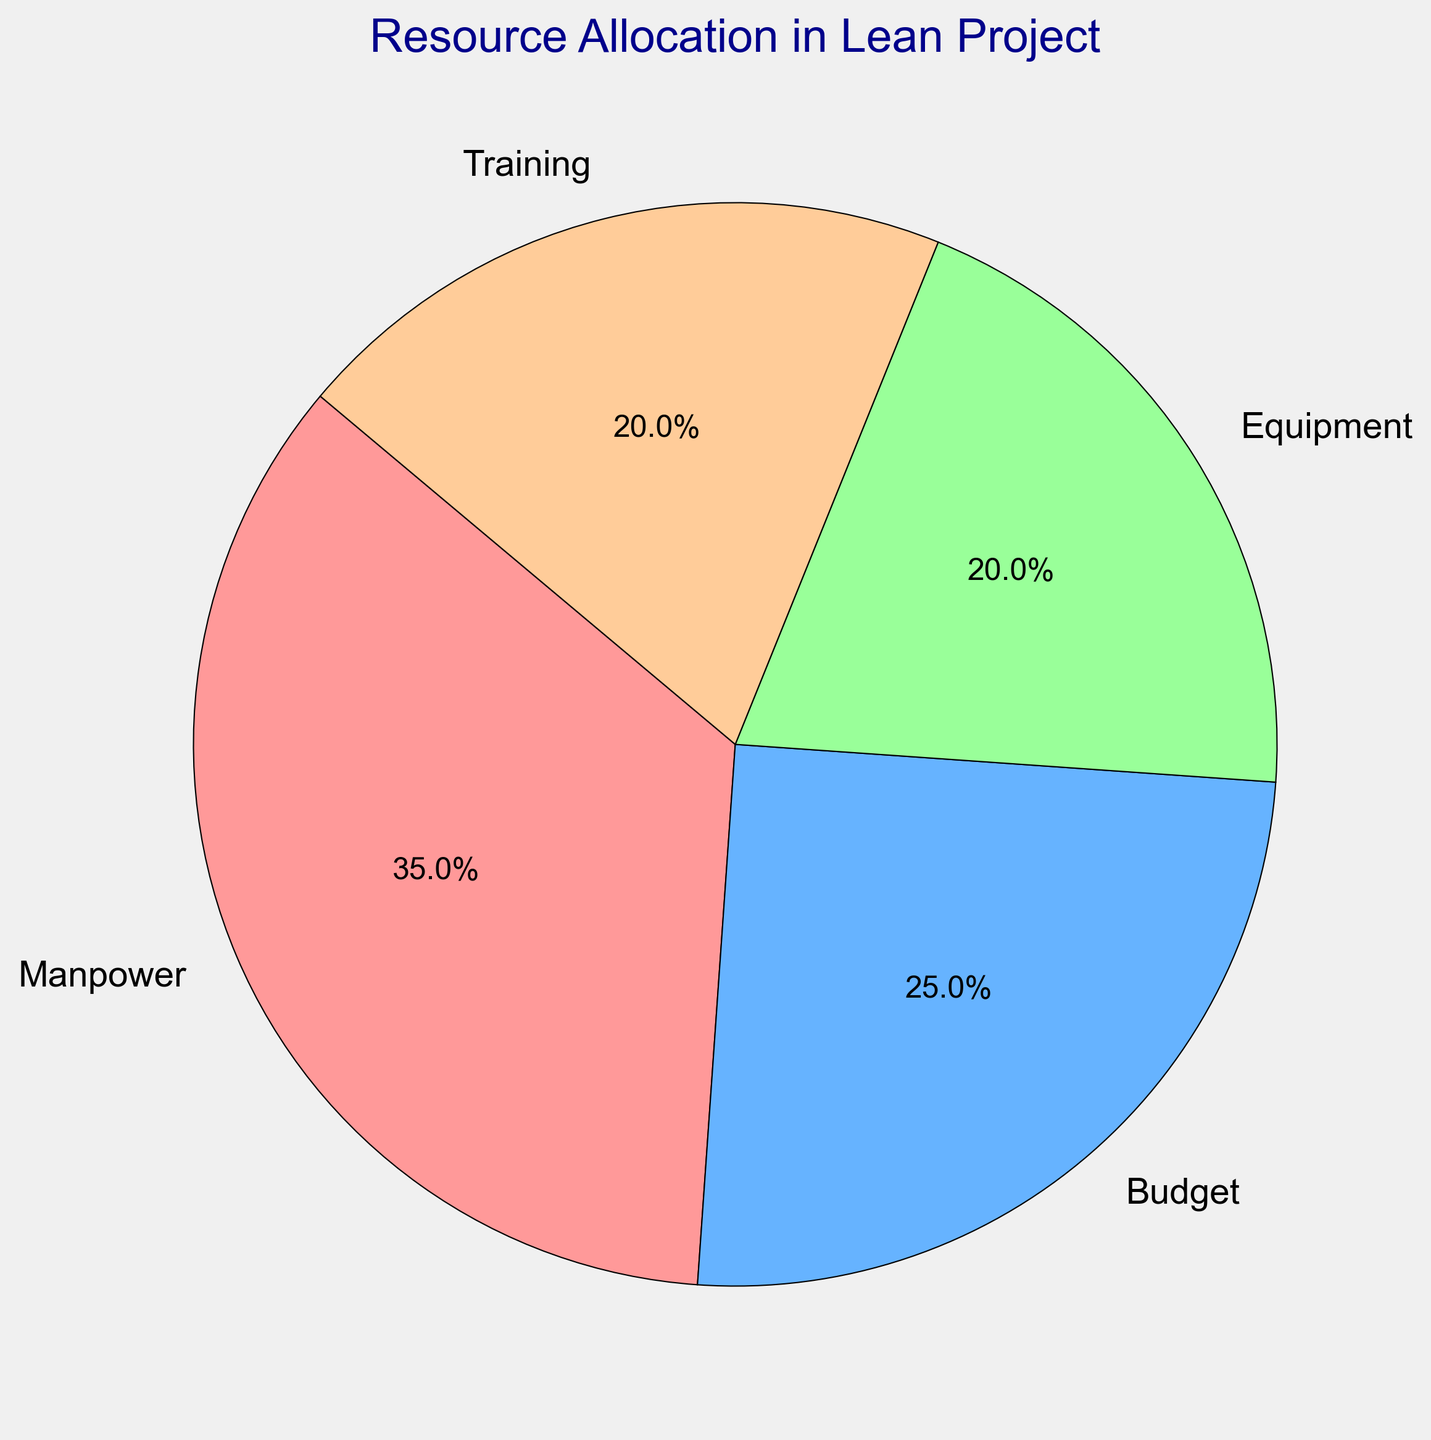What is the percentage allocated to Training? Look at the slice of the pie chart labeled "Training" and refer to the percentage written inside or next to it.
Answer: 20% Which category uses the most resources? Identify the slice of the pie chart that has the largest area and the highest percentage number. This is the category with the most resources allocated.
Answer: Manpower What's the combined percentage allocated to Equipment and Training? Add the percentage from the slices labeled "Equipment" and "Training". The Equipment slice is 20% and the Training slice is also 20%. So, 20% + 20% = 40%.
Answer: 40% How much more resource percentage is allocated to Manpower than Budget? Find the percentage for Manpower (35%) and Budget (25%) and subtract the smaller percentage from the larger one: 35% - 25% = 10%.
Answer: 10% Is the percentage allocation to Budget greater or less than that to Equipment? Compare the percentages directly from the chart: Budget is 25% and Equipment is 20%. 25% is greater than 20%, so Budget is greater.
Answer: Budget is greater What is the average percentage allocation for Equipment and Training? Add the percentages for Equipment (20%) and Training (20%) and then divide by the number of categories (2). (20% + 20%) / 2 = 20%.
Answer: 20% Which two categories combined represent half of the total resource allocation? Examine pairs of categories and add their percentages, looking for a total of 50%. Manpower is 35% and Budget is 25%, together they make 60%. Equipment and Training both have 20%, totaling 40%. Only Manpower (35%) and Equipment (20%) together make 55%. Manpower and Training again total 55%. Finally, Budget (25%) and Equipment (20%) make 45%. Looking through, none make exactly 50%. Hence, no two categories precisely represent half of the total allocation.
Answer: None If the allocation to Equipment increases by 5%, which category or categories will remain lower than Equipment? Add 5% to the Equipment slice; it was 20%, so it becomes 25%. Compare the new Equipment percentage with Training (20%) and Budget (25%). Training is 20%, which is less than 25%, so only Training remains lower.
Answer: Training Which color represents Manpower in the pie chart? Identify the slice labeled "Manpower" and note the color used for this slice. Since color names aren't specified directly, suppose it is red by standard assignment in the legend.
Answer: Red 